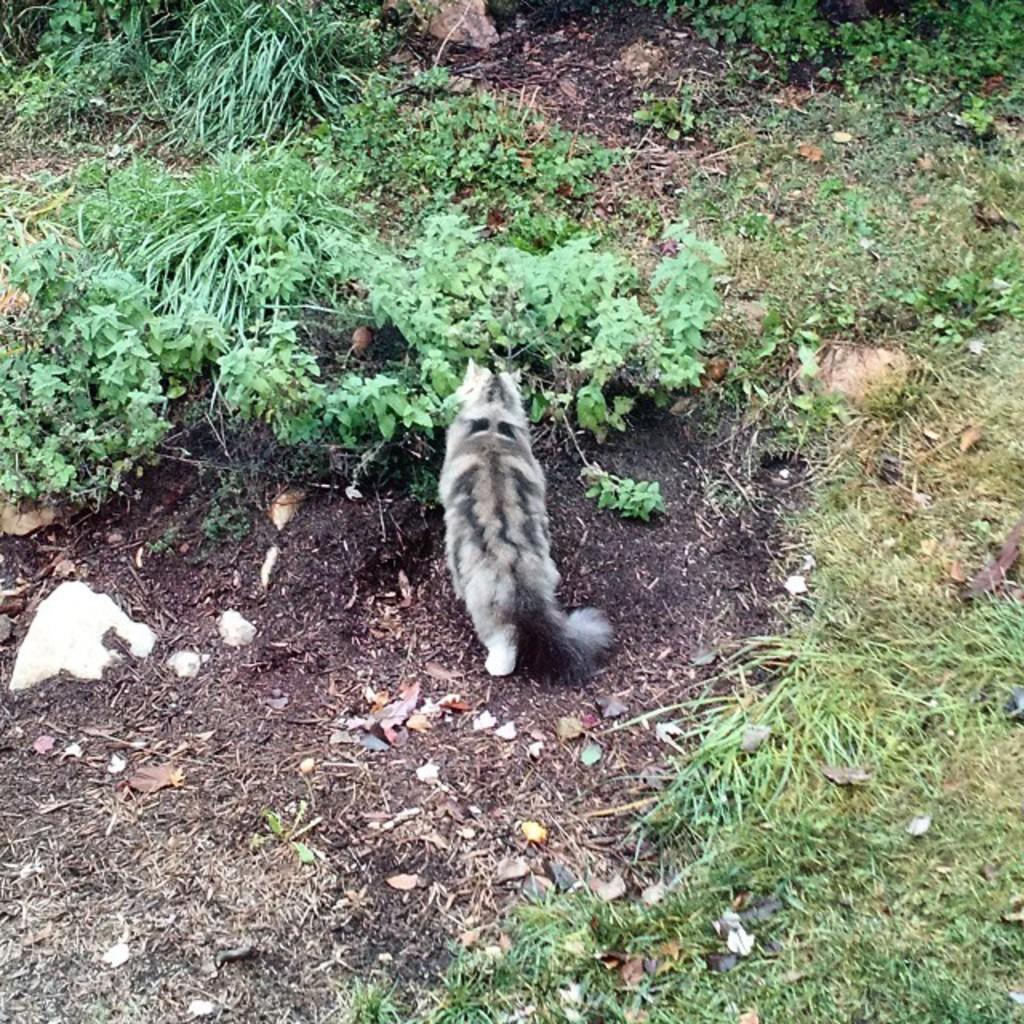What is the main subject in the center of the image? There is an animal in the center of the image. What type of vegetation is present at the bottom of the image? There is grass at the bottom of the image. What can be seen in the background of the image? There are shrubs in the background of the image. What is the purpose of the comb in the image? There is no comb present in the image. 